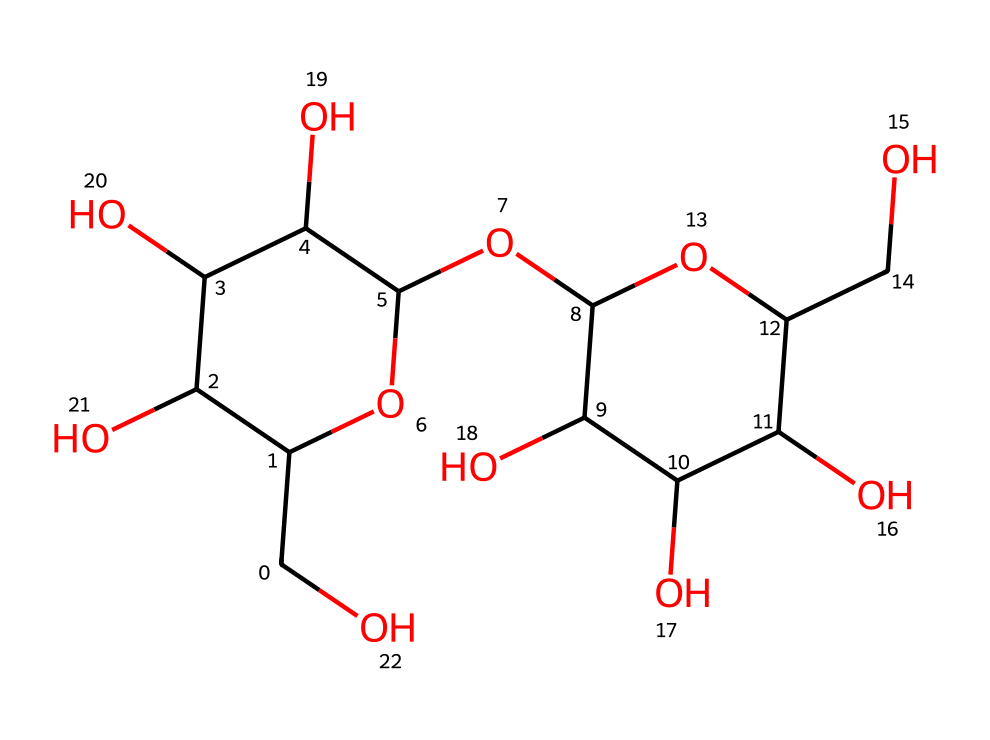What is the molecular formula of lactose? By examining the structure, we can identify the number of carbon (C), hydrogen (H), and oxygen (O) atoms present. The molecule includes 12 carbon atoms, 22 hydrogen atoms, and 11 oxygen atoms, resulting in the molecular formula C12H22O11.
Answer: C12H22O11 How many rings are present in the structure of lactose? Analyzing the SMILES representation, we see that it contains two cyclic structures indicated by the numbers 1 and 2, which are used to denote the start and end of each ring. Therefore, there are two rings in lactose.
Answer: 2 What type of carbohydrate is lactose classified as? Given the structural composition and the presence of glycosidic bonds, lactose is a disaccharide, which consists of two monosaccharides (glucose and galactose) linked together.
Answer: disaccharide What functional groups can be found in lactose? By looking at the structure, we can identify hydroxyl (-OH) groups as functional groups attached to various carbon atoms, confirming that lactose has multiple alcohol functional groups, which are characteristic of carbohydrates.
Answer: hydroxyl groups What is the linkage type between the monosaccharides in lactose? The linkage between glucose and galactose in lactose is a β(1→4) glycosidic bond, indicated by the orientation of the hydroxyl groups involved in the bond formation. This specific bond is critical in defining lactose as a carbohydrate and its properties.
Answer: β(1→4) glycosidic bond 